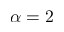Convert formula to latex. <formula><loc_0><loc_0><loc_500><loc_500>\alpha = 2</formula> 